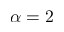Convert formula to latex. <formula><loc_0><loc_0><loc_500><loc_500>\alpha = 2</formula> 